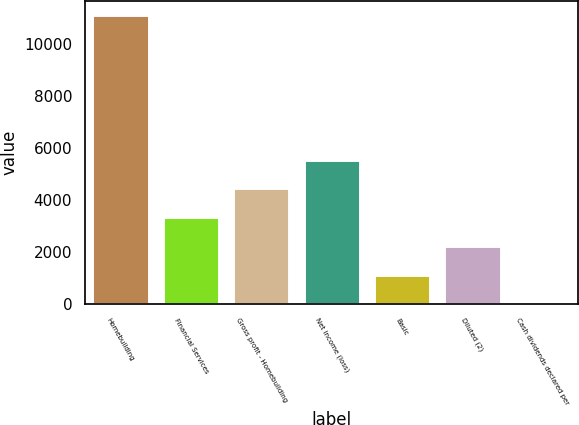<chart> <loc_0><loc_0><loc_500><loc_500><bar_chart><fcel>Homebuilding<fcel>Financial Services<fcel>Gross profit - Homebuilding<fcel>Net income (loss)<fcel>Basic<fcel>Diluted (2)<fcel>Cash dividends declared per<nl><fcel>11088.8<fcel>3327.06<fcel>4435.88<fcel>5544.7<fcel>1109.42<fcel>2218.24<fcel>0.6<nl></chart> 